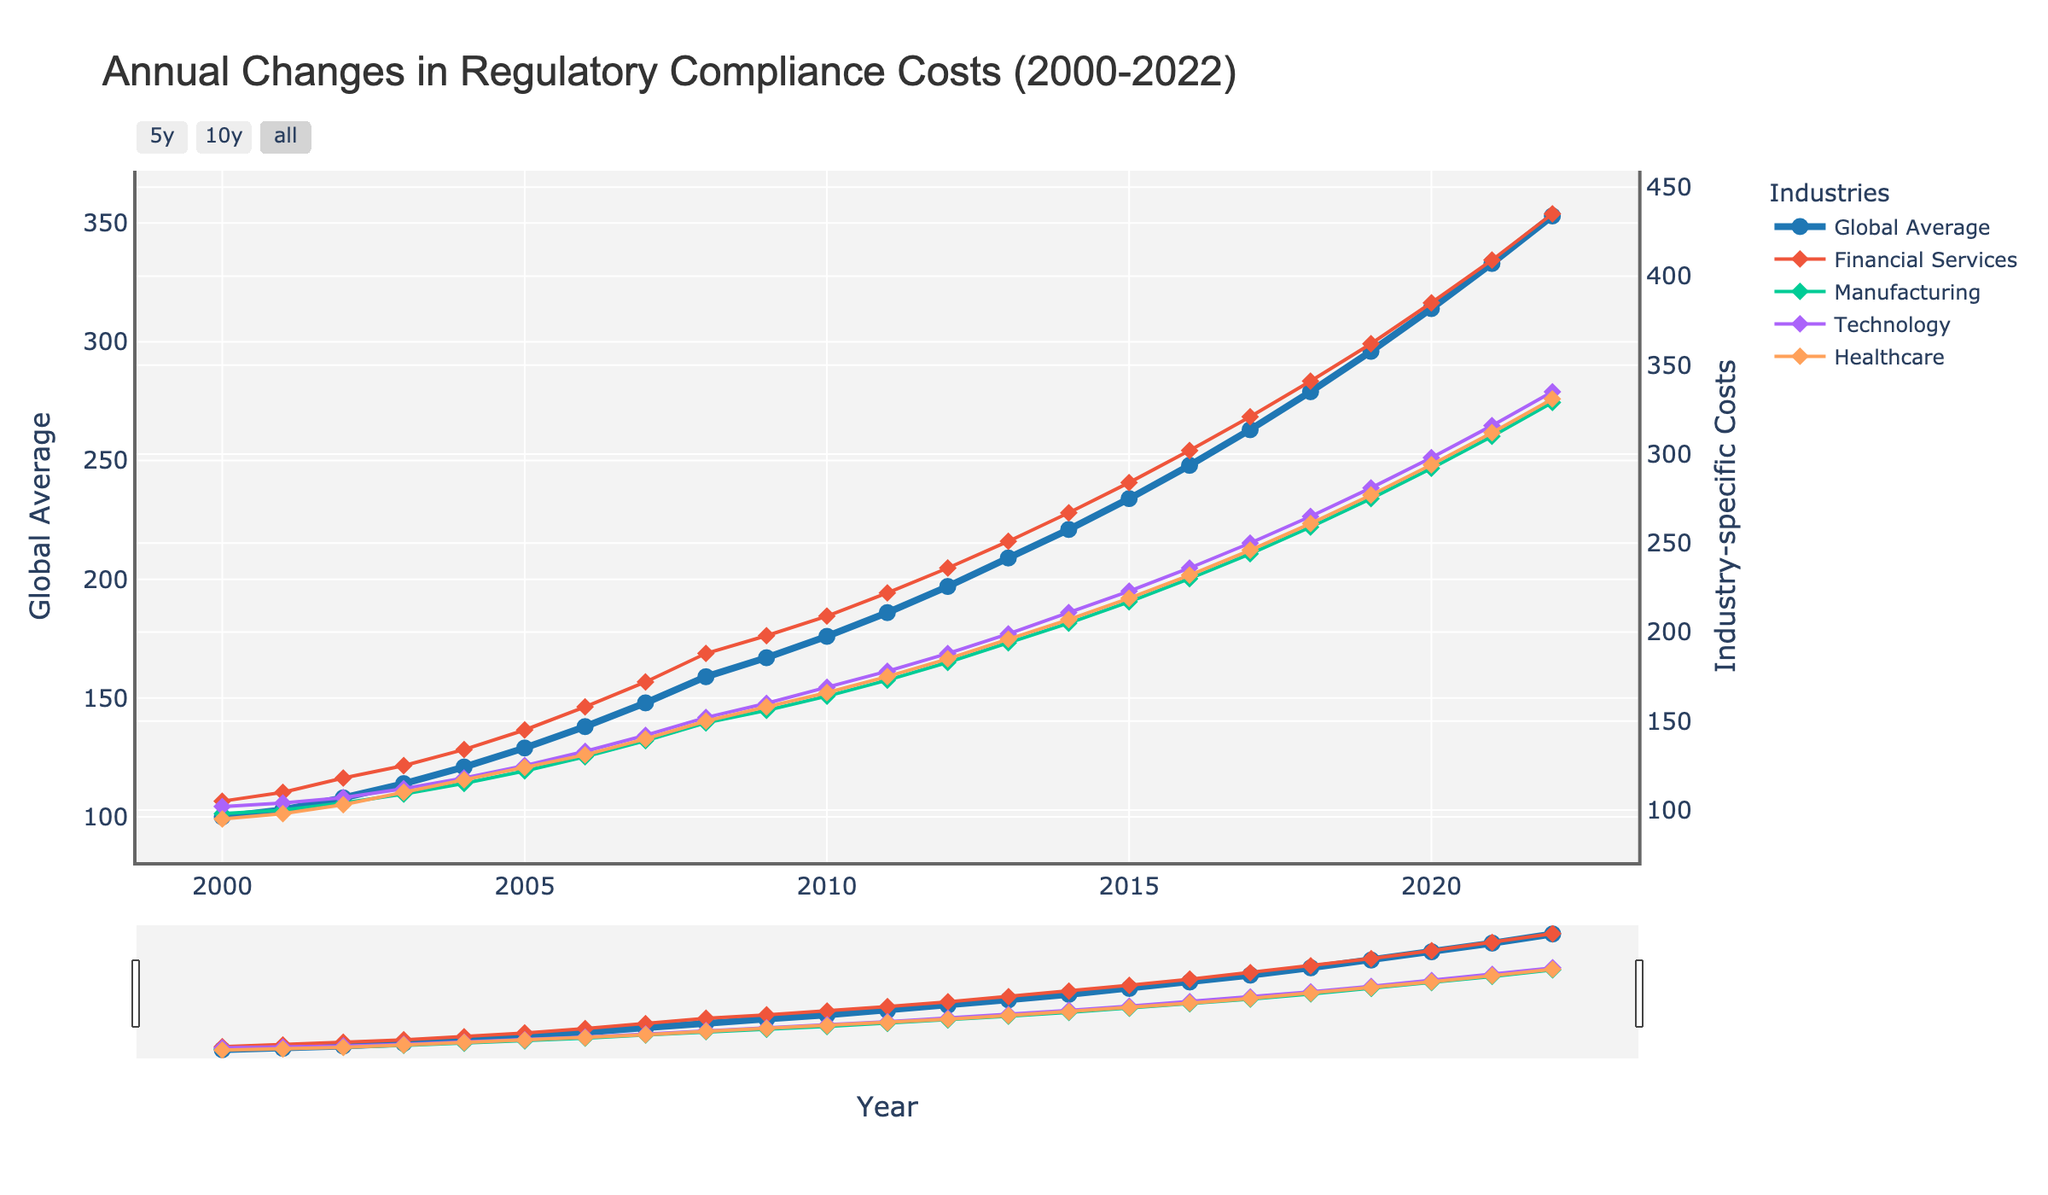What was the global average regulatory compliance cost in 2010? According to the chart, the global average in 2010 can be read directly from the 'Global Average' line at the year 2010.
Answer: 176 Which industry had the highest regulatory compliance costs in 2022? By examining the chart lines for the year 2022, the 'Financial Services' line is the highest amongst all the industries represented.
Answer: Financial Services What is the percentage increase in global average regulatory compliance costs from 2000 to 2022? Calculate the increase from 2000 to 2022: (353 - 100) / 100 * 100%. First, find the difference which is 353 - 100 = 253. Then, (253 / 100) * 100% = 253%.
Answer: 253% By how much did the regulatory compliance cost in the healthcare industry increase from 2008 to 2018? Locate the costs for the healthcare industry in 2008 and 2018. They are 150 and 261, respectively. The increase is 261 - 150 = 111.
Answer: 111 During which year(s) did the technology industry see the most significant year-over-year increase in compliance costs? To identify this, look at the year-over-year increments in the technology industry's line. The biggest jump appears from 2007 to 2008, from a value of 142 to 152, an increase of 10 units.
Answer: 2007-2008 Compare the compliance costs in the manufacturing and healthcare industries in 2015. Which one was higher? By how much? Locate the 2015 data points for both industries: Manufacturing is 217 and Healthcare is 219. Healthcare is higher by 219 - 217 = 2 units.
Answer: Healthcare by 2 units In which year did the global average regulatory compliance cost cross 200 units for the first time? Check the 'Global Average' line on the chart to see when it first exceeds 200 units. This occurs in 2013.
Answer: 2013 What is the average regulatory compliance cost in the technology industry over the entire period? Sum the technology industry's costs from 2000 to 2022 and divide by the number of years (23). The sum is 102 + 104 + 107 + 112 + 118 + 125 + 133 + 142 + 152 + 160 + 169 + 178 + 188 + 199 + 211 + 223 + 236 + 250 + 265 + 281 + 298 + 316 + 335 = 5024. 5024 / 23 ≈ 218.43.
Answer: 218.43 